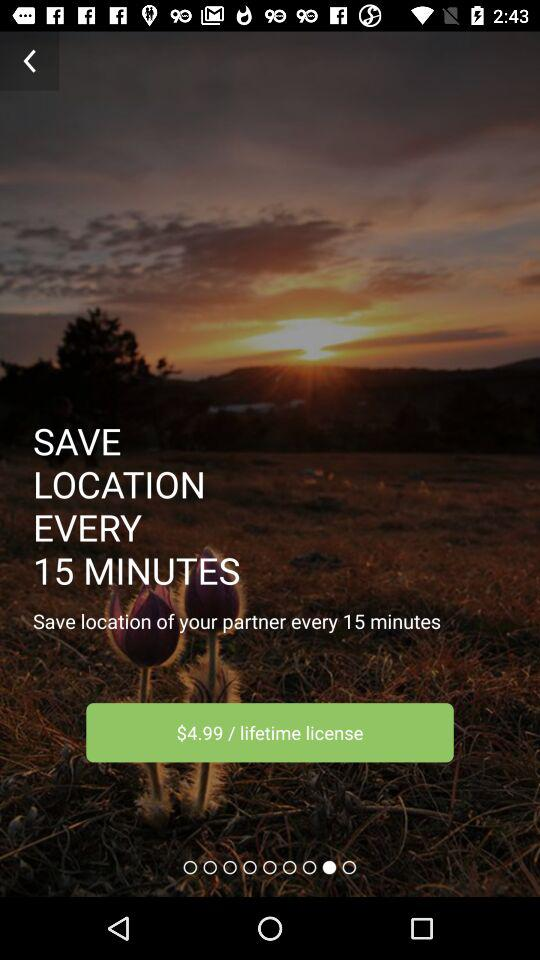What is the time duration to save a location? The time duration to save a location is every 15 minutes. 